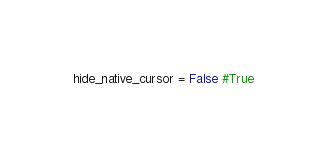<code> <loc_0><loc_0><loc_500><loc_500><_Python_>hide_native_cursor = False #True
</code> 